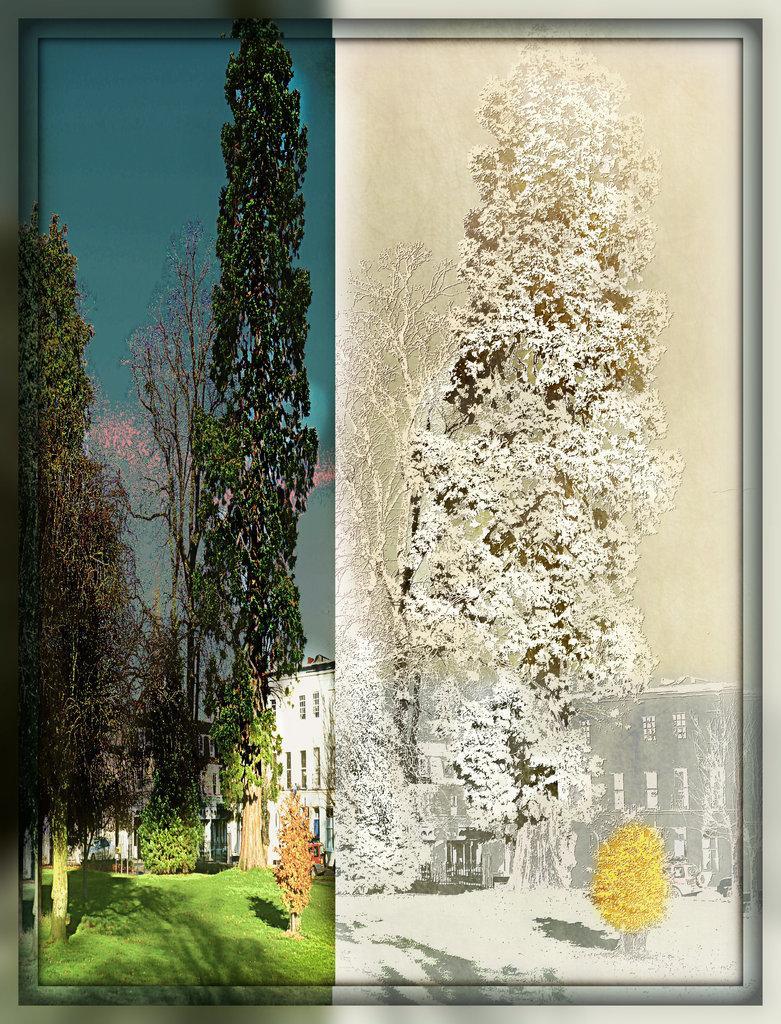Can you describe this image briefly? This is an edited and made as collage image. In the right side image I can see few trees, a building and a plant are covered with snow. In the left side image, at the bottom of the image I can see the grass. In the background there are some trees and a building. At the top I can see the sky. 